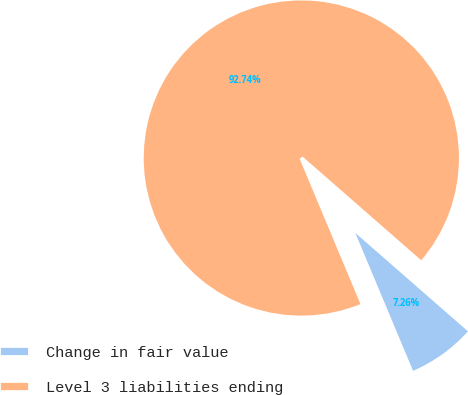Convert chart to OTSL. <chart><loc_0><loc_0><loc_500><loc_500><pie_chart><fcel>Change in fair value<fcel>Level 3 liabilities ending<nl><fcel>7.26%<fcel>92.74%<nl></chart> 